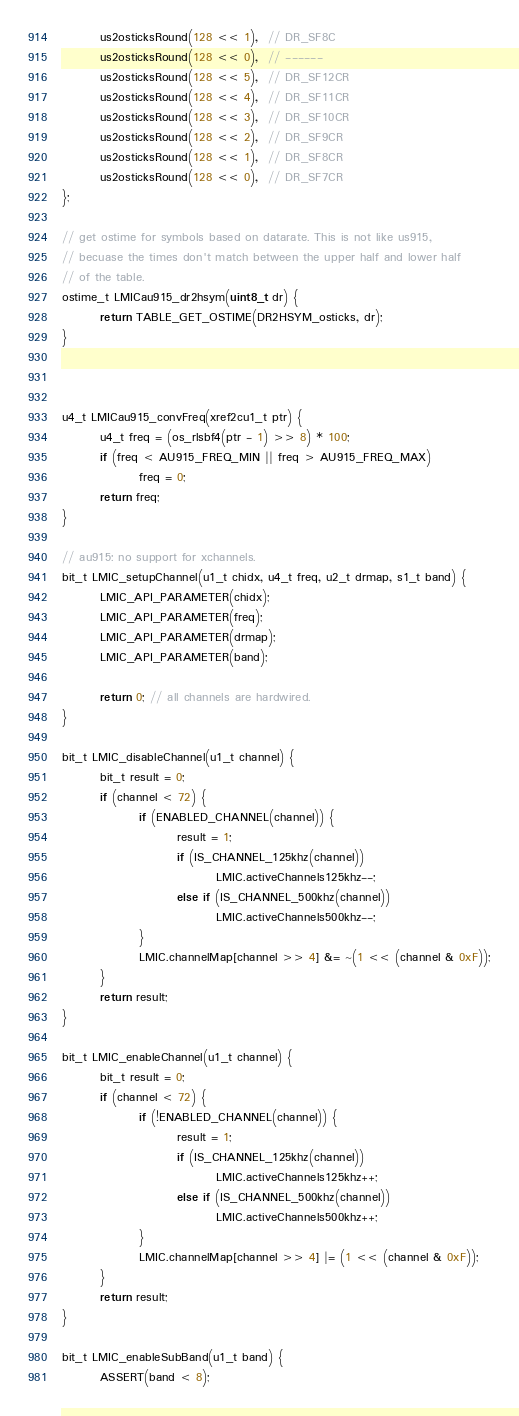<code> <loc_0><loc_0><loc_500><loc_500><_C_>        us2osticksRound(128 << 1),  // DR_SF8C
        us2osticksRound(128 << 0),  // ------
        us2osticksRound(128 << 5),  // DR_SF12CR
        us2osticksRound(128 << 4),  // DR_SF11CR
        us2osticksRound(128 << 3),  // DR_SF10CR
        us2osticksRound(128 << 2),  // DR_SF9CR
        us2osticksRound(128 << 1),  // DR_SF8CR
        us2osticksRound(128 << 0),  // DR_SF7CR
};

// get ostime for symbols based on datarate. This is not like us915,
// becuase the times don't match between the upper half and lower half
// of the table.
ostime_t LMICau915_dr2hsym(uint8_t dr) {
        return TABLE_GET_OSTIME(DR2HSYM_osticks, dr);
}



u4_t LMICau915_convFreq(xref2cu1_t ptr) {
        u4_t freq = (os_rlsbf4(ptr - 1) >> 8) * 100;
        if (freq < AU915_FREQ_MIN || freq > AU915_FREQ_MAX)
                freq = 0;
        return freq;
}

// au915: no support for xchannels.
bit_t LMIC_setupChannel(u1_t chidx, u4_t freq, u2_t drmap, s1_t band) {
        LMIC_API_PARAMETER(chidx);
        LMIC_API_PARAMETER(freq);
        LMIC_API_PARAMETER(drmap);
        LMIC_API_PARAMETER(band);

        return 0; // all channels are hardwired.
}

bit_t LMIC_disableChannel(u1_t channel) {
        bit_t result = 0;
        if (channel < 72) {
                if (ENABLED_CHANNEL(channel)) {
                        result = 1;
                        if (IS_CHANNEL_125khz(channel))
                                LMIC.activeChannels125khz--;
                        else if (IS_CHANNEL_500khz(channel))
                                LMIC.activeChannels500khz--;
                }
                LMIC.channelMap[channel >> 4] &= ~(1 << (channel & 0xF));
        }
        return result;
}

bit_t LMIC_enableChannel(u1_t channel) {
        bit_t result = 0;
        if (channel < 72) {
                if (!ENABLED_CHANNEL(channel)) {
                        result = 1;
                        if (IS_CHANNEL_125khz(channel))
                                LMIC.activeChannels125khz++;
                        else if (IS_CHANNEL_500khz(channel))
                                LMIC.activeChannels500khz++;
                }
                LMIC.channelMap[channel >> 4] |= (1 << (channel & 0xF));
        }
        return result;
}

bit_t LMIC_enableSubBand(u1_t band) {
        ASSERT(band < 8);</code> 